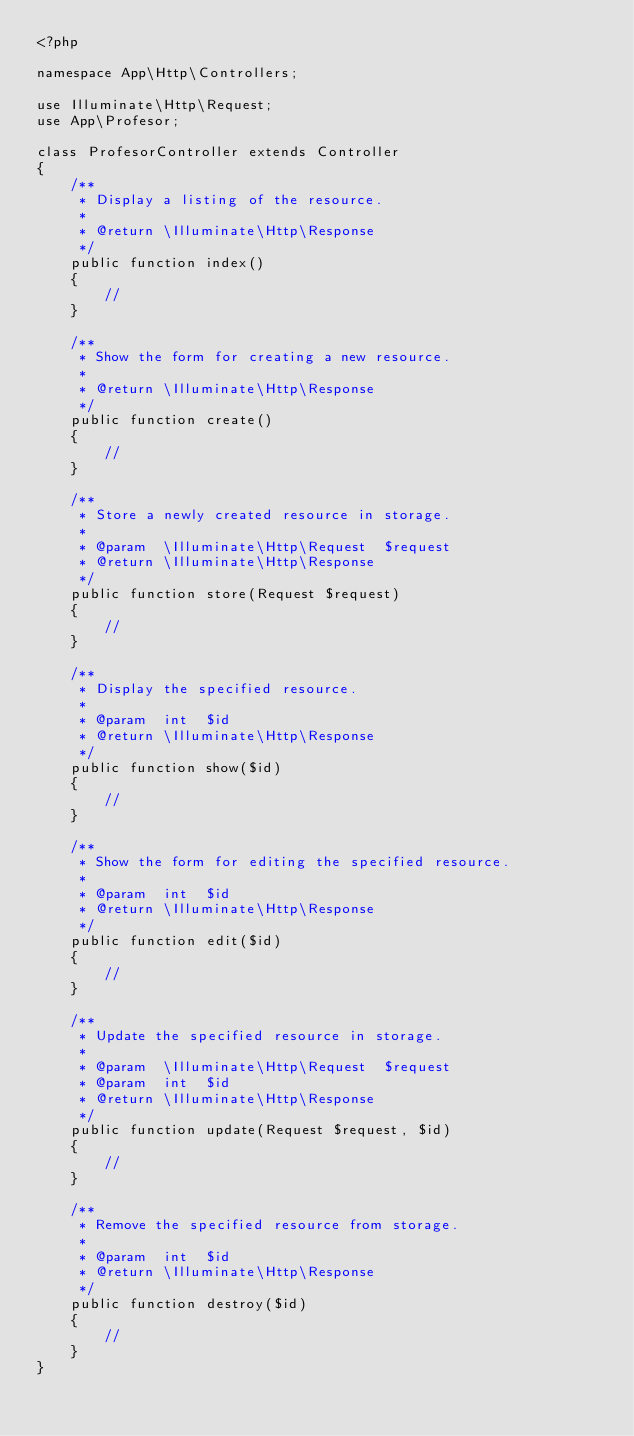Convert code to text. <code><loc_0><loc_0><loc_500><loc_500><_PHP_><?php

namespace App\Http\Controllers;

use Illuminate\Http\Request;
use App\Profesor;

class ProfesorController extends Controller
{
    /**
     * Display a listing of the resource.
     *
     * @return \Illuminate\Http\Response
     */
    public function index()
    {
        //
    }

    /**
     * Show the form for creating a new resource.
     *
     * @return \Illuminate\Http\Response
     */
    public function create()
    {
        //
    }

    /**
     * Store a newly created resource in storage.
     *
     * @param  \Illuminate\Http\Request  $request
     * @return \Illuminate\Http\Response
     */
    public function store(Request $request)
    {
        //
    }

    /**
     * Display the specified resource.
     *
     * @param  int  $id
     * @return \Illuminate\Http\Response
     */
    public function show($id)
    {
        //
    }

    /**
     * Show the form for editing the specified resource.
     *
     * @param  int  $id
     * @return \Illuminate\Http\Response
     */
    public function edit($id)
    {
        //
    }

    /**
     * Update the specified resource in storage.
     *
     * @param  \Illuminate\Http\Request  $request
     * @param  int  $id
     * @return \Illuminate\Http\Response
     */
    public function update(Request $request, $id)
    {
        //
    }

    /**
     * Remove the specified resource from storage.
     *
     * @param  int  $id
     * @return \Illuminate\Http\Response
     */
    public function destroy($id)
    {
        //
    }
}
</code> 